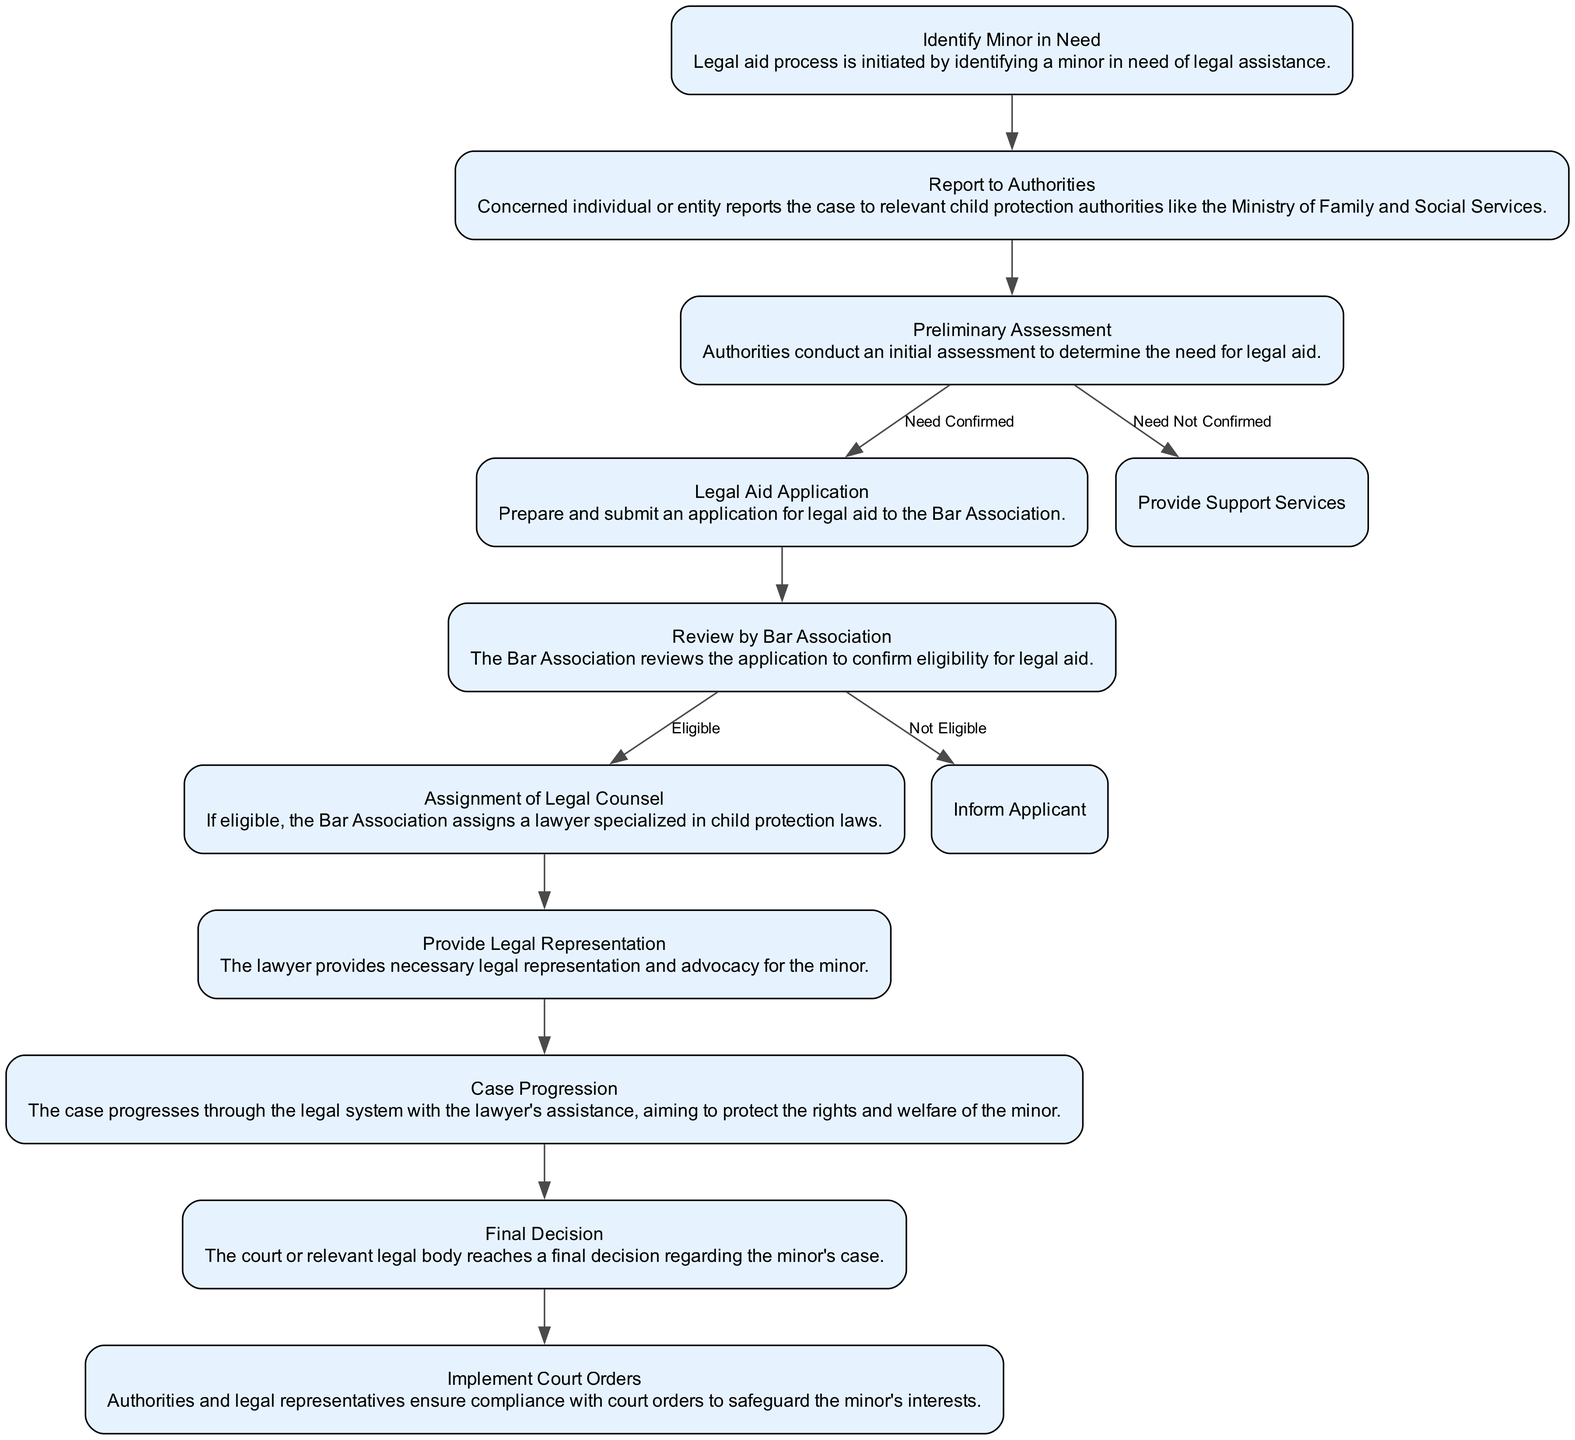What is the first step in the legal aid procedure for minors? The diagram starts with the node "Identify Minor in Need," indicating that this is the initial step in the legal aid process.
Answer: Identify Minor in Need How many major steps are there in the diagram? By counting the nodes representing major steps in the flow chart, I identify ten key steps in the process, which include Identify Minor in Need through to Implement Court Orders.
Answer: 10 What is the outcome if the Preliminary Assessment confirms the need for legal aid? According to the diagram, if the Preliminary Assessment confirms the need, it leads directly to the next step labeled "Legal Aid Application."
Answer: Legal Aid Application What occurs after the Review by Bar Association if the applicant is eligible? The next action, as indicated in the diagram, is the "Assignment of Legal Counsel," which occurs after the applicant is deemed eligible for legal aid.
Answer: Assignment of Legal Counsel What action must be taken after the Final Decision? The diagram specifies that after reaching a Final Decision, the next step is to "Implement Court Orders," making this the required action to follow.
Answer: Implement Court Orders If a minor is identified as needing aid, which authorities must be reported to? The next step specifies reporting to relevant child protection authorities, primarily "the Ministry of Family and Social Services" as indicated in the flow.
Answer: Authorities like the Ministry of Family and Social Services What happens if the Review by Bar Association deems the application not eligible? The flow chart states that if the application is not eligible, the next step is "Inform Applicant," which is the appropriate action in this case.
Answer: Inform Applicant What leads to the case progression within the legal system? After providing legal representation, which is the previous step, the case progresses through the legal system with the lawyer's assistance, as indicated in the flow chart.
Answer: Case Progression What is the purpose of the “Provide Legal Representation”? This step serves to ensure necessary legal representation and advocacy for the minor, according to the description provided in the flowchart.
Answer: Legal representation and advocacy for the minor 